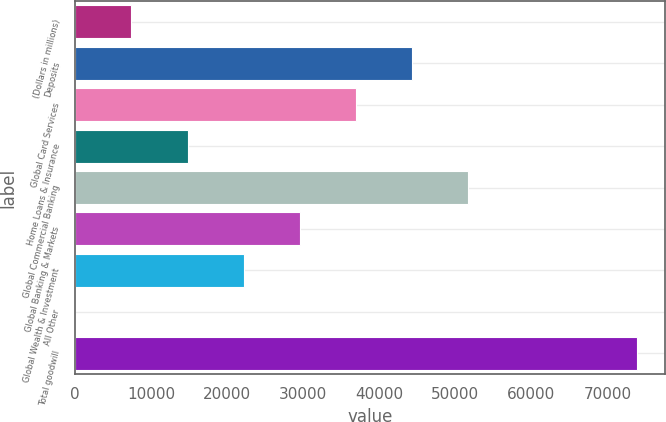<chart> <loc_0><loc_0><loc_500><loc_500><bar_chart><fcel>(Dollars in millions)<fcel>Deposits<fcel>Global Card Services<fcel>Home Loans & Insurance<fcel>Global Commercial Banking<fcel>Global Banking & Markets<fcel>Global Wealth & Investment<fcel>All Other<fcel>Total goodwill<nl><fcel>7417.6<fcel>44330.6<fcel>36948<fcel>14800.2<fcel>51713.2<fcel>29565.4<fcel>22182.8<fcel>35<fcel>73861<nl></chart> 